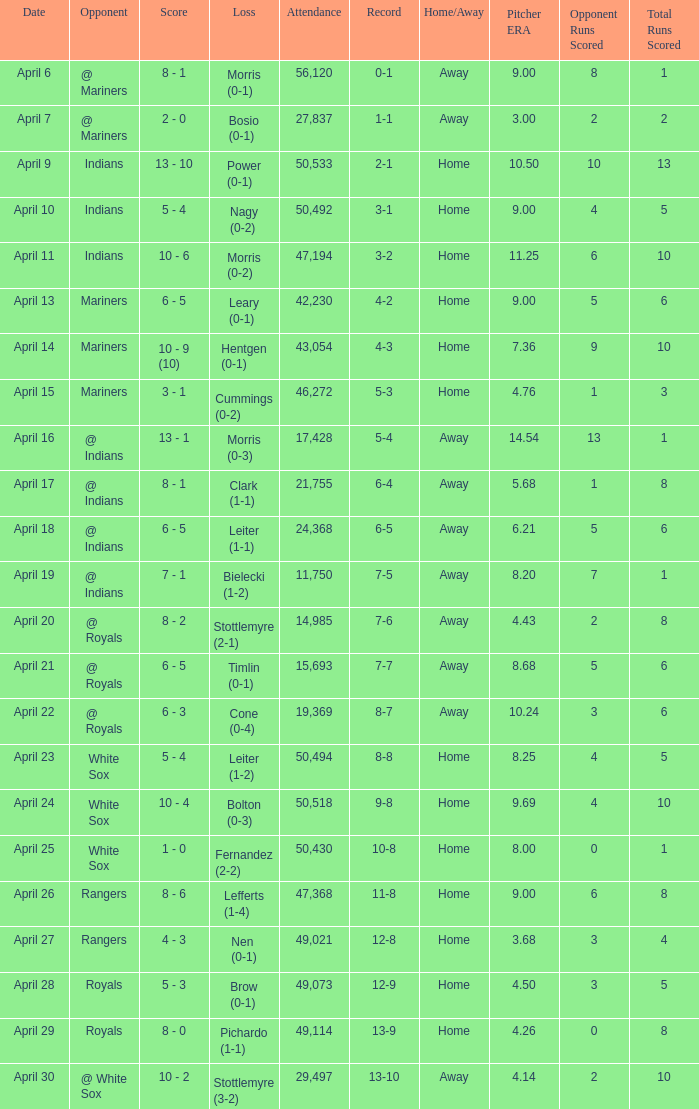What scored is recorded on April 24? 10 - 4. 